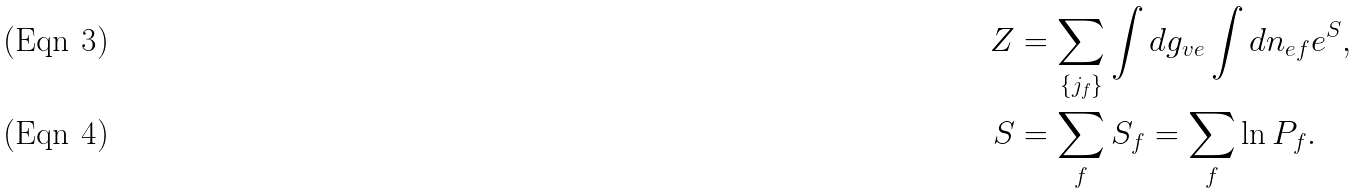Convert formula to latex. <formula><loc_0><loc_0><loc_500><loc_500>Z & = \sum _ { \{ j _ { f } \} } \int d g _ { v e } \int d n _ { e f } e ^ { S } , \\ S & = \sum _ { f } S _ { f } = \sum _ { f } \ln P _ { f } .</formula> 